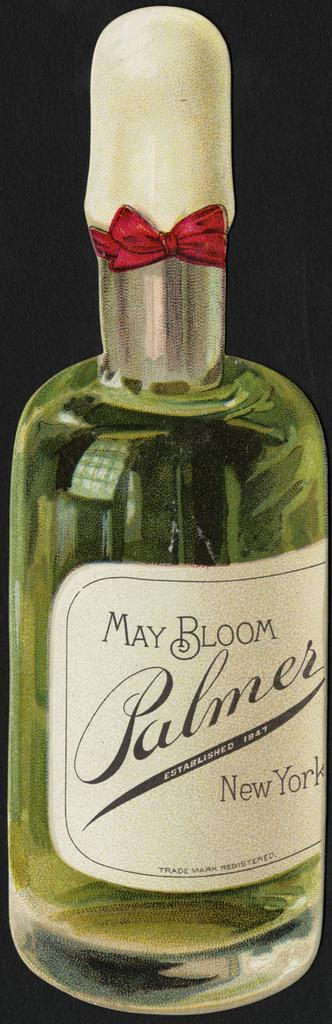<image>
Offer a succinct explanation of the picture presented. A bottle of May Bloom Palmer from New York. 